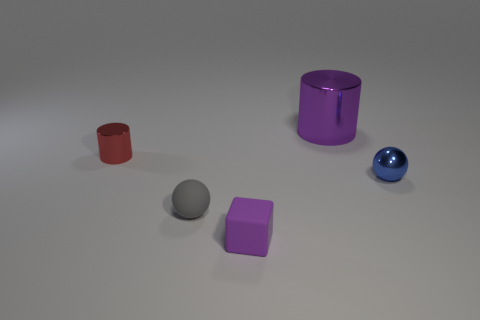What is the size of the cylinder that is the same color as the tiny block?
Give a very brief answer. Large. Is the material of the tiny purple cube the same as the purple cylinder?
Provide a succinct answer. No. What number of metallic objects are big purple things or purple cubes?
Provide a short and direct response. 1. There is a matte sphere that is the same size as the purple rubber thing; what color is it?
Keep it short and to the point. Gray. What number of other metal objects are the same shape as the large purple shiny thing?
Your response must be concise. 1. How many cylinders are either blue objects or small gray things?
Provide a succinct answer. 0. There is a big purple metallic thing that is behind the rubber block; does it have the same shape as the shiny object left of the big purple object?
Offer a very short reply. Yes. What is the large cylinder made of?
Your response must be concise. Metal. The thing that is the same color as the small rubber cube is what shape?
Make the answer very short. Cylinder. What number of spheres have the same size as the purple matte cube?
Make the answer very short. 2. 